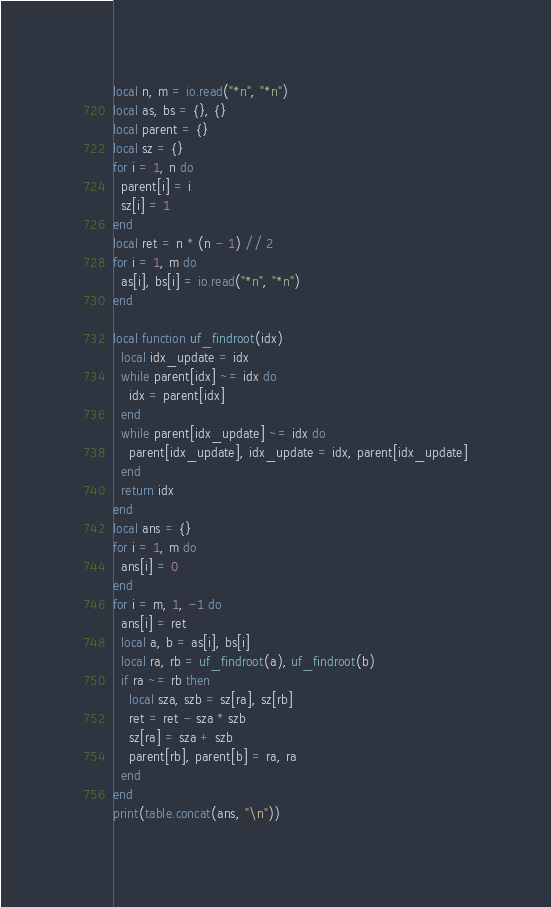Convert code to text. <code><loc_0><loc_0><loc_500><loc_500><_Lua_>local n, m = io.read("*n", "*n")
local as, bs = {}, {}
local parent = {}
local sz = {}
for i = 1, n do
  parent[i] = i
  sz[i] = 1
end
local ret = n * (n - 1) // 2
for i = 1, m do
  as[i], bs[i] = io.read("*n", "*n")
end

local function uf_findroot(idx)
  local idx_update = idx
  while parent[idx] ~= idx do
    idx = parent[idx]
  end
  while parent[idx_update] ~= idx do
    parent[idx_update], idx_update = idx, parent[idx_update]
  end
  return idx
end
local ans = {}
for i = 1, m do
  ans[i] = 0
end
for i = m, 1, -1 do
  ans[i] = ret
  local a, b = as[i], bs[i]
  local ra, rb = uf_findroot(a), uf_findroot(b)
  if ra ~= rb then
    local sza, szb = sz[ra], sz[rb]
    ret = ret - sza * szb
    sz[ra] = sza + szb
    parent[rb], parent[b] = ra, ra
  end
end
print(table.concat(ans, "\n"))
</code> 